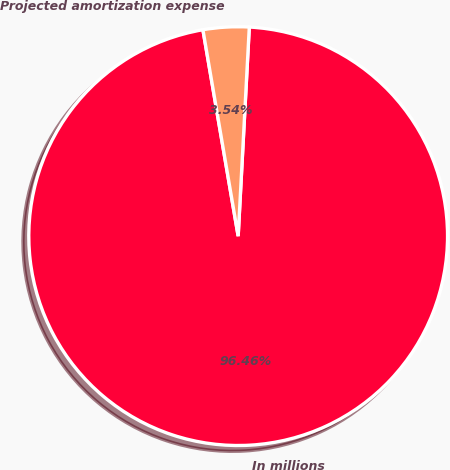Convert chart. <chart><loc_0><loc_0><loc_500><loc_500><pie_chart><fcel>In millions<fcel>Projected amortization expense<nl><fcel>96.46%<fcel>3.54%<nl></chart> 